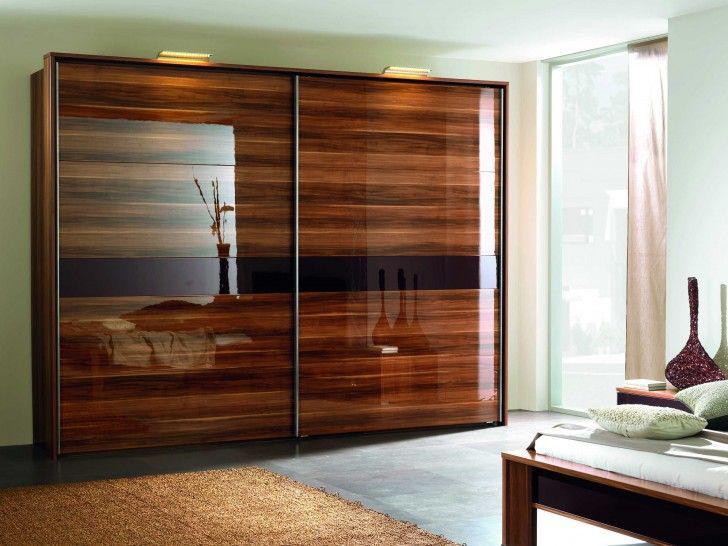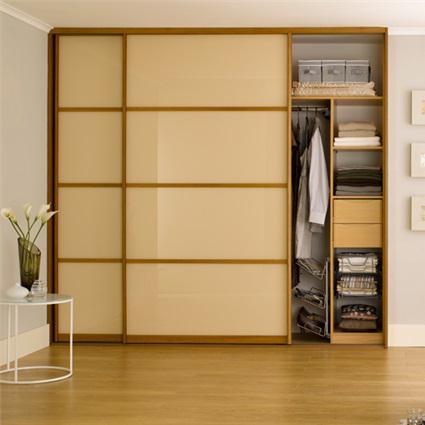The first image is the image on the left, the second image is the image on the right. Assess this claim about the two images: "There are clothes visible in one of the closets.". Correct or not? Answer yes or no. Yes. The first image is the image on the left, the second image is the image on the right. Examine the images to the left and right. Is the description "An image shows a wardrobe with pale beige panels and the sliding door partly open." accurate? Answer yes or no. Yes. 